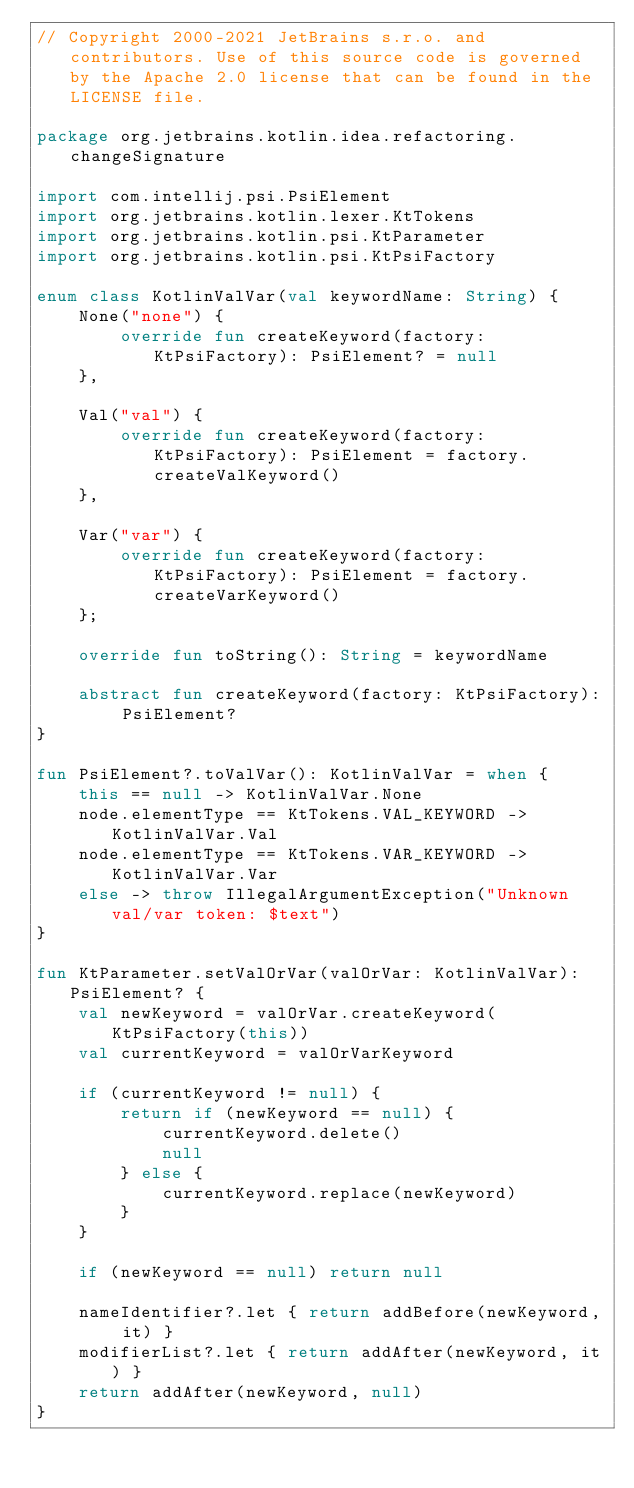Convert code to text. <code><loc_0><loc_0><loc_500><loc_500><_Kotlin_>// Copyright 2000-2021 JetBrains s.r.o. and contributors. Use of this source code is governed by the Apache 2.0 license that can be found in the LICENSE file.

package org.jetbrains.kotlin.idea.refactoring.changeSignature

import com.intellij.psi.PsiElement
import org.jetbrains.kotlin.lexer.KtTokens
import org.jetbrains.kotlin.psi.KtParameter
import org.jetbrains.kotlin.psi.KtPsiFactory

enum class KotlinValVar(val keywordName: String) {
    None("none") {
        override fun createKeyword(factory: KtPsiFactory): PsiElement? = null
    },

    Val("val") {
        override fun createKeyword(factory: KtPsiFactory): PsiElement = factory.createValKeyword()
    },

    Var("var") {
        override fun createKeyword(factory: KtPsiFactory): PsiElement = factory.createVarKeyword()
    };

    override fun toString(): String = keywordName

    abstract fun createKeyword(factory: KtPsiFactory): PsiElement?
}

fun PsiElement?.toValVar(): KotlinValVar = when {
    this == null -> KotlinValVar.None
    node.elementType == KtTokens.VAL_KEYWORD -> KotlinValVar.Val
    node.elementType == KtTokens.VAR_KEYWORD -> KotlinValVar.Var
    else -> throw IllegalArgumentException("Unknown val/var token: $text")
}

fun KtParameter.setValOrVar(valOrVar: KotlinValVar): PsiElement? {
    val newKeyword = valOrVar.createKeyword(KtPsiFactory(this))
    val currentKeyword = valOrVarKeyword

    if (currentKeyword != null) {
        return if (newKeyword == null) {
            currentKeyword.delete()
            null
        } else {
            currentKeyword.replace(newKeyword)
        }
    }

    if (newKeyword == null) return null

    nameIdentifier?.let { return addBefore(newKeyword, it) }
    modifierList?.let { return addAfter(newKeyword, it) }
    return addAfter(newKeyword, null)
}</code> 